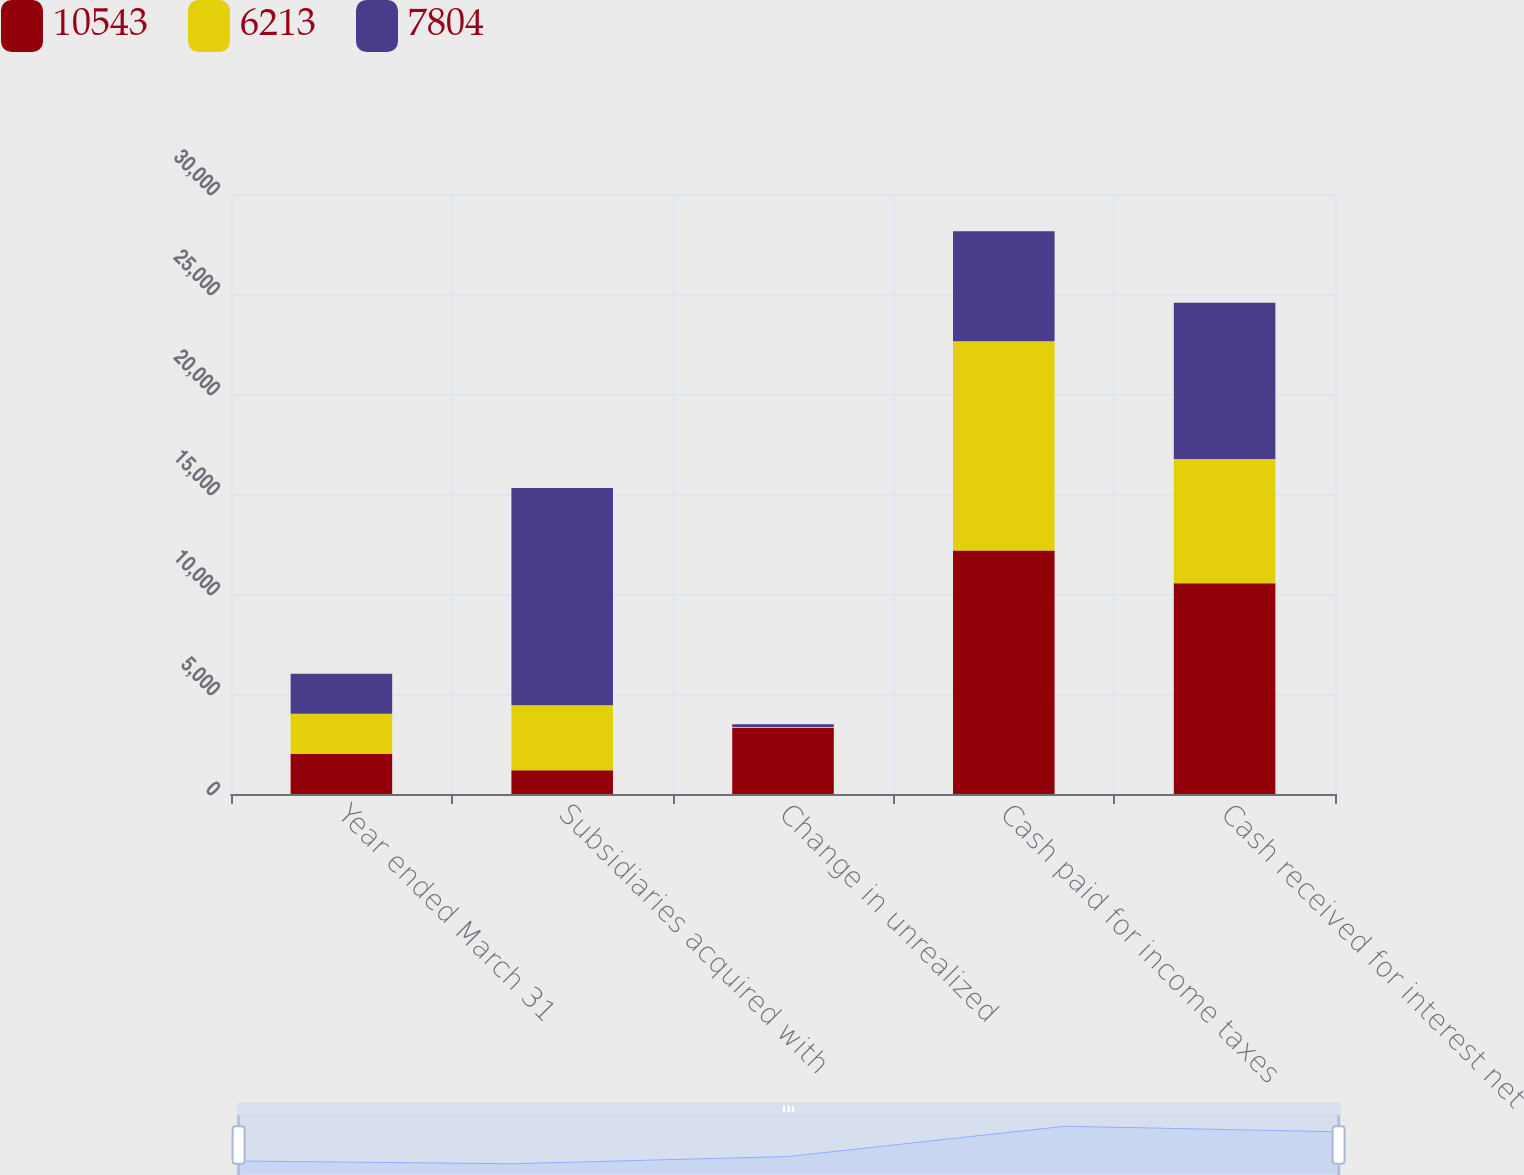Convert chart. <chart><loc_0><loc_0><loc_500><loc_500><stacked_bar_chart><ecel><fcel>Year ended March 31<fcel>Subsidiaries acquired with<fcel>Change in unrealized<fcel>Cash paid for income taxes<fcel>Cash received for interest net<nl><fcel>10543<fcel>2005<fcel>1191<fcel>3317<fcel>12178<fcel>10543<nl><fcel>6213<fcel>2004<fcel>3246<fcel>37<fcel>10463<fcel>6213<nl><fcel>7804<fcel>2003<fcel>10861<fcel>134<fcel>5491<fcel>7804<nl></chart> 